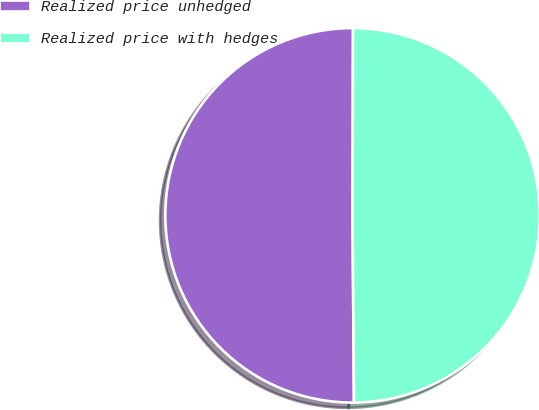<chart> <loc_0><loc_0><loc_500><loc_500><pie_chart><fcel>Realized price unhedged<fcel>Realized price with hedges<nl><fcel>50.16%<fcel>49.84%<nl></chart> 